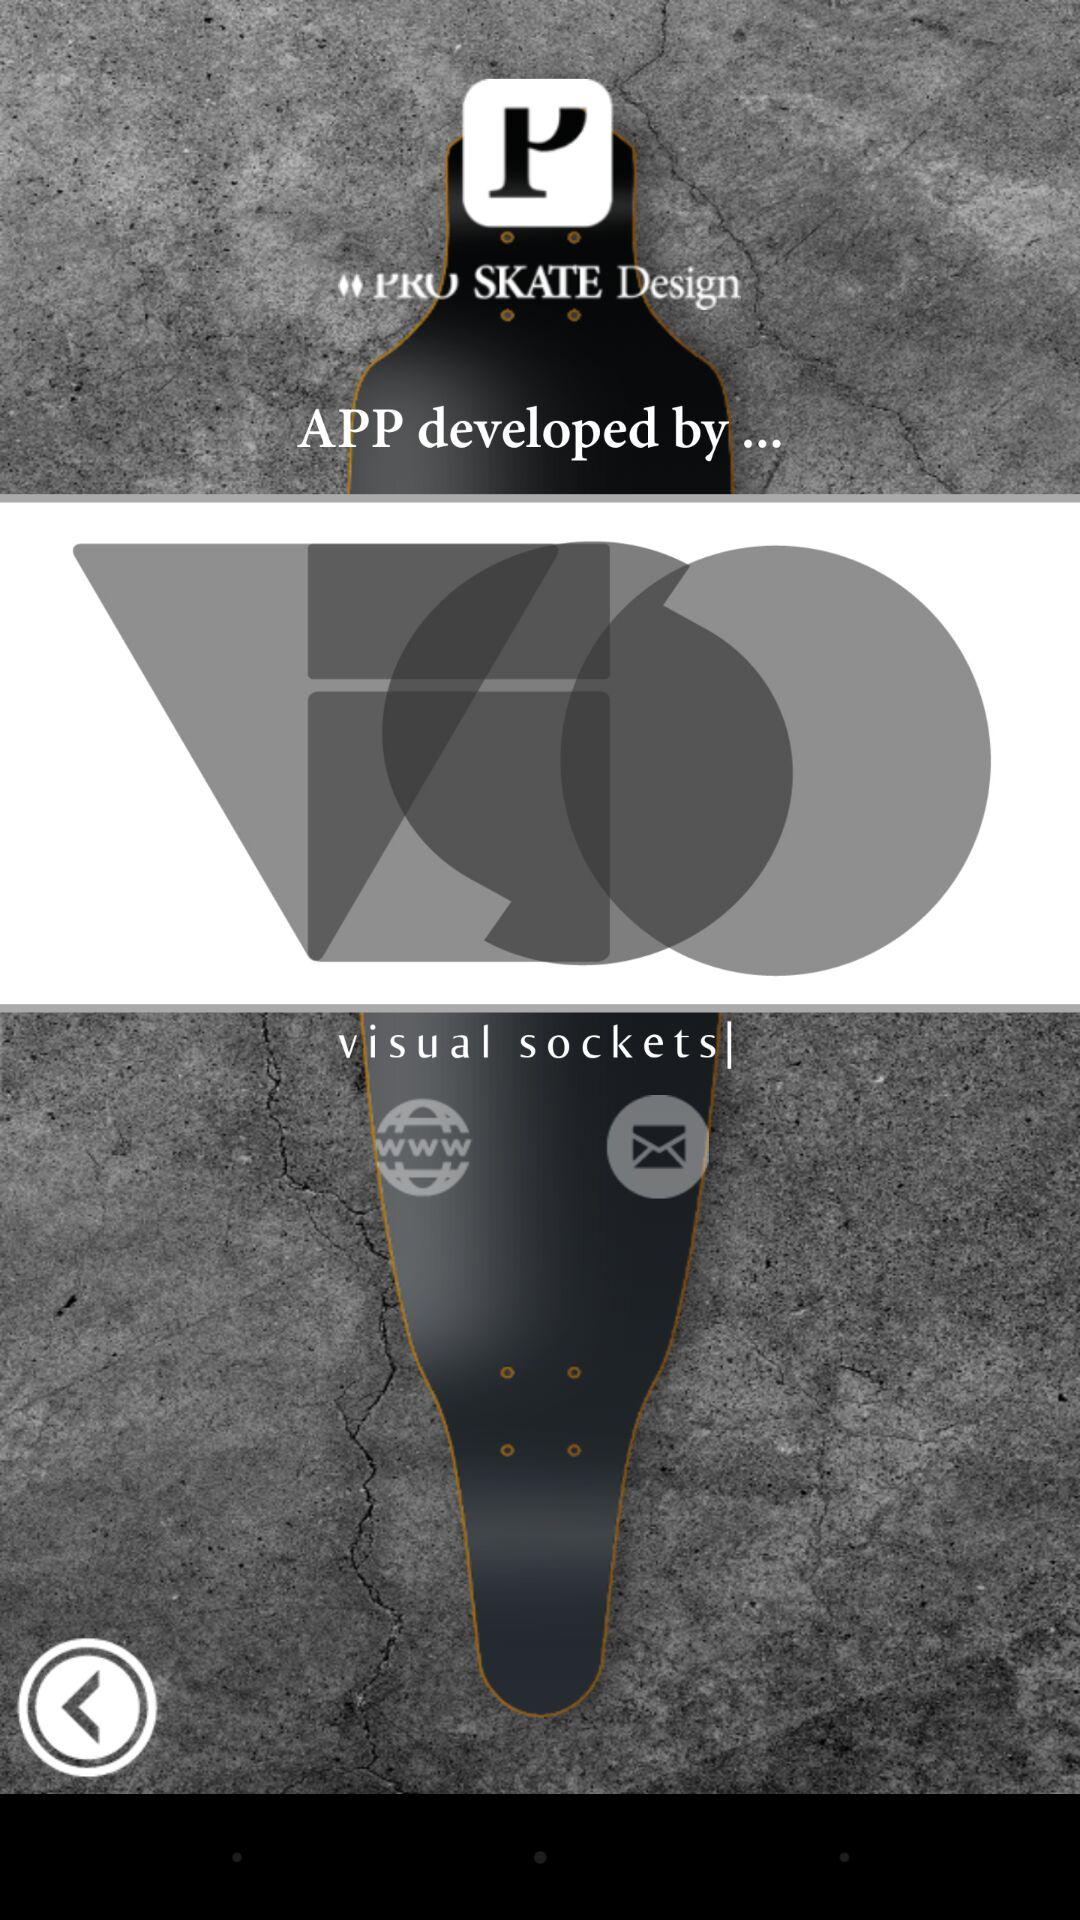Who developed the application? The application was developed by Visual Sockets. 